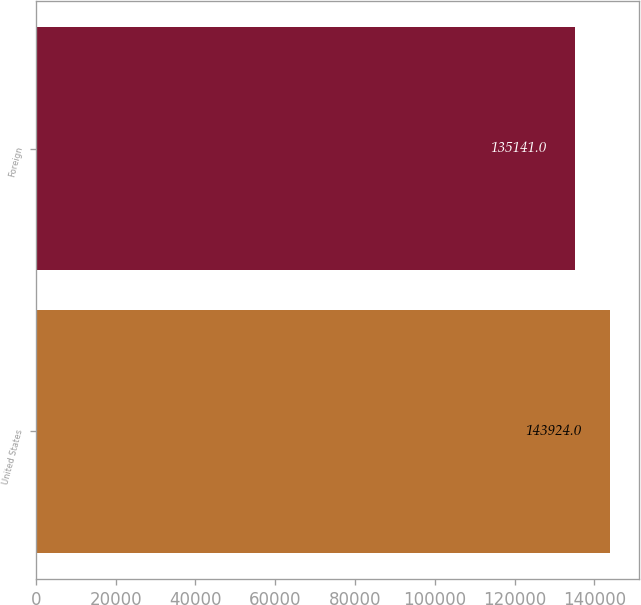<chart> <loc_0><loc_0><loc_500><loc_500><bar_chart><fcel>United States<fcel>Foreign<nl><fcel>143924<fcel>135141<nl></chart> 